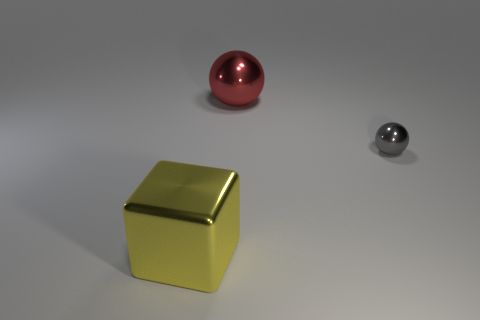Add 1 big yellow shiny things. How many objects exist? 4 Subtract all balls. How many objects are left? 1 Subtract 0 blue cylinders. How many objects are left? 3 Subtract all red shiny things. Subtract all yellow objects. How many objects are left? 1 Add 1 big metallic things. How many big metallic things are left? 3 Add 3 small gray metallic objects. How many small gray metallic objects exist? 4 